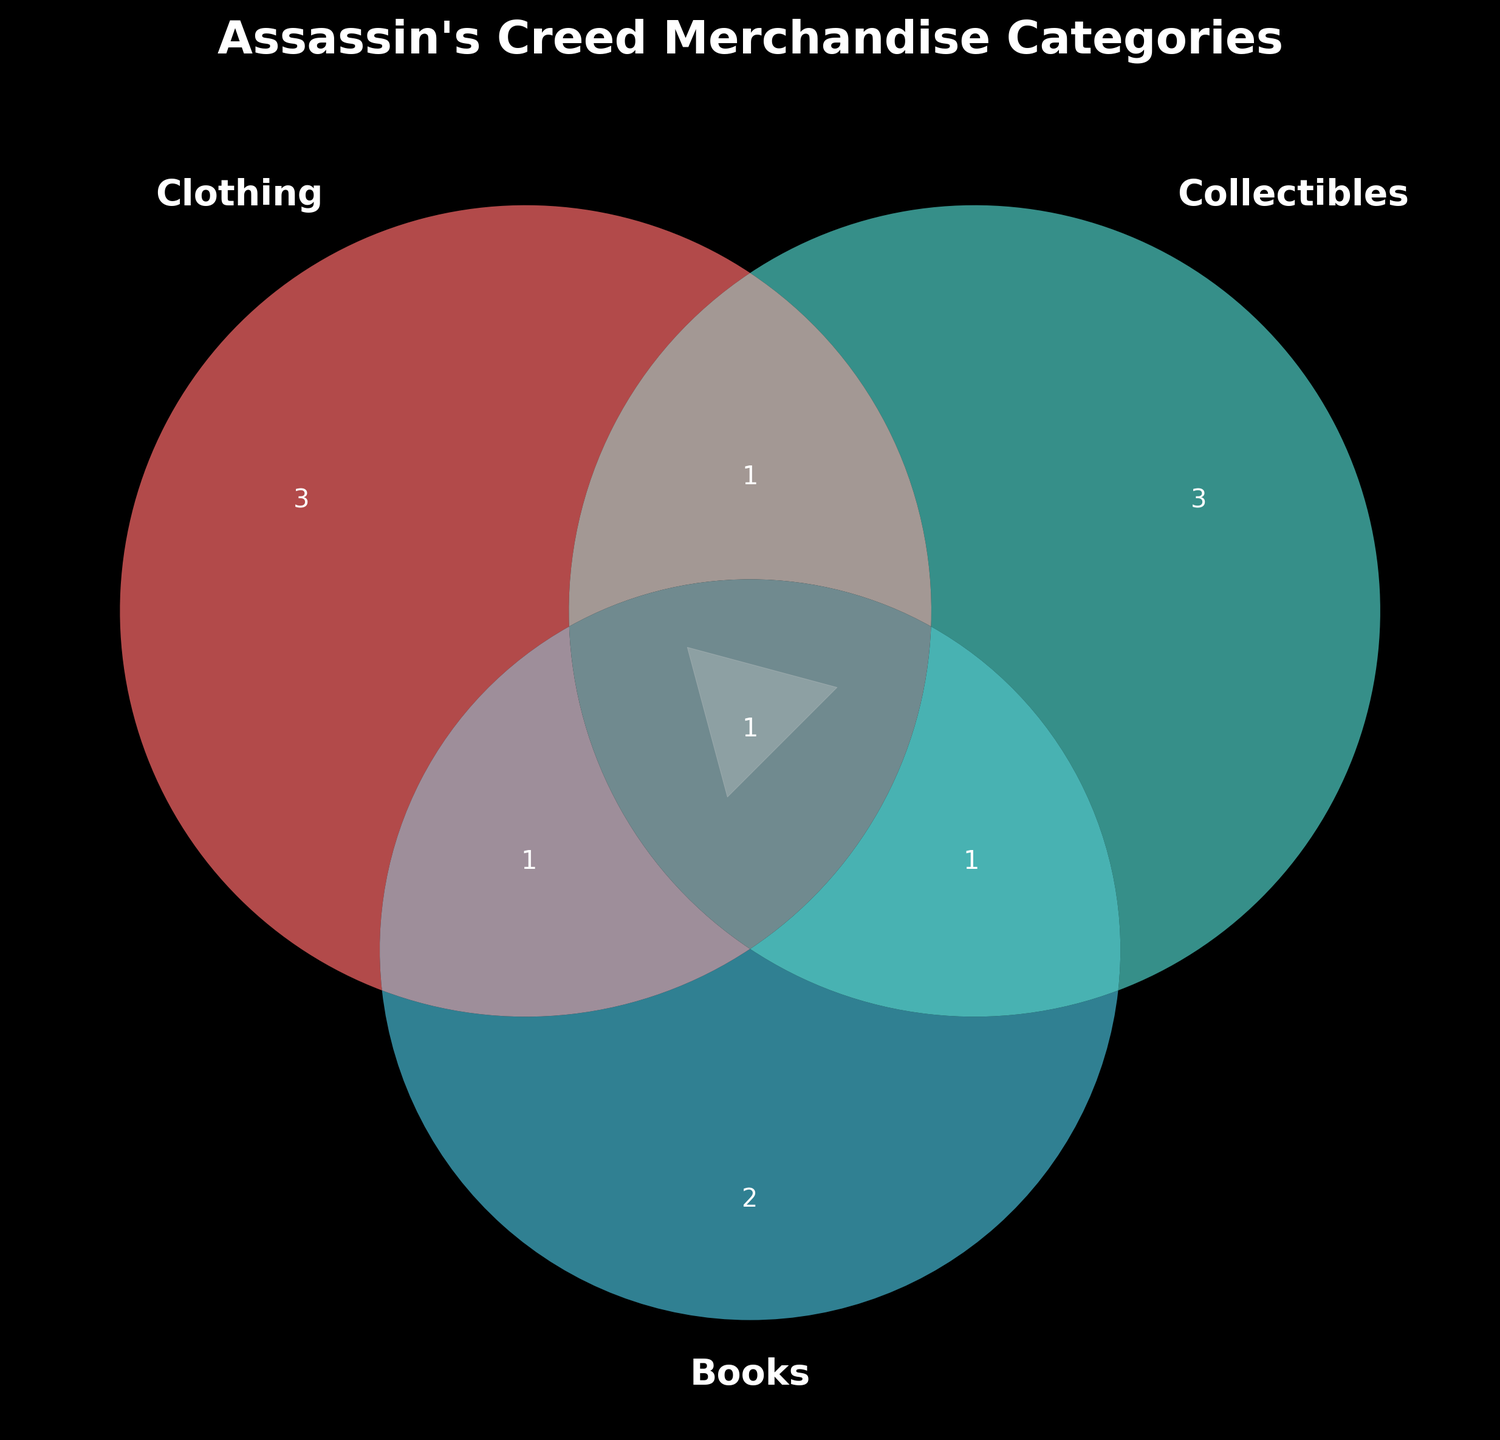What is the title of the Venn diagram? The title of a figure is usually found at the top-center. Observing the top of the Venn diagram, we can see the text "Assassin's Creed Merchandise Categories."
Answer: Assassin's Creed Merchandise Categories How many items are in the Clothing & Books category? Look for the section where the Clothing and Books circles intersect but not Collectibles. The text label in this section reveals 1 item.
Answer: 1 Which category has the most exclusive items? Count the items within each single category (excluding intersections). Clothing has 3, Collectibles has 3, and Books has 2. Both Clothing and Collectibles have the most exclusives.
Answer: Clothing and Collectibles How many items belong to multiple categories? Count the items in overlapping areas (Clothing & Collectibles, Clothing & Books, Collectibles & Books, and Clothing & Collectibles & Books). We see 1 item in C&C, 1 in C&B, 1 in C&B, and 1 in all three categories. Adding them gives 1 + 1 + 1 + 1 = 4 items.
Answer: 4 Which item appears in all three categories? Locate the intersection where all three circles overlap. The text label shows "Assassin's Creed Ultimate Fan Pack."
Answer: Assassin's Creed Ultimate Fan Pack How many items are in the category Collectibles & Books but not Clothing? Look at the intersection between Collectibles and Books without including Clothing. The text label shows 1 item in that section.
Answer: 1 Is there any item that belongs to both Clothing and Collectibles categories? Locate the overlap between Clothing and Collectibles circles. The text label indicates there is 1 item.
Answer: Yes How many total unique items are there in the diagram? Sum the items in each section (3 Clothing, 3 Collectibles, 2 Books, 1 C&C, 1 C&B, 1 C&B, 1 All Three) which yields 3 + 3 + 2 + 1 + 1 + 1 + 1 = 12 total unique items.
Answer: 12 